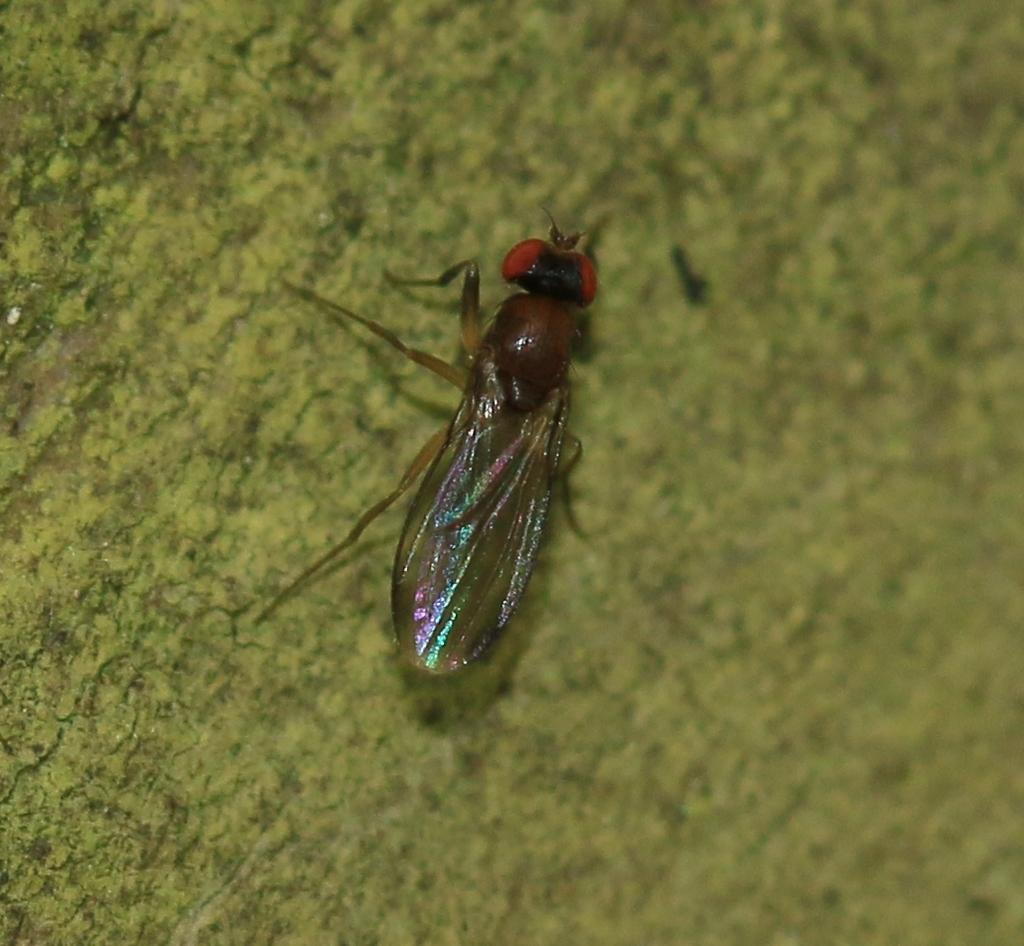What type of creature is present in the image? There is an insect in the image. What is the insect resting on in the image? The insect is on a green surface. What type of arch can be seen in the background of the image? There is no arch present in the image; it only features an insect on a green surface. 